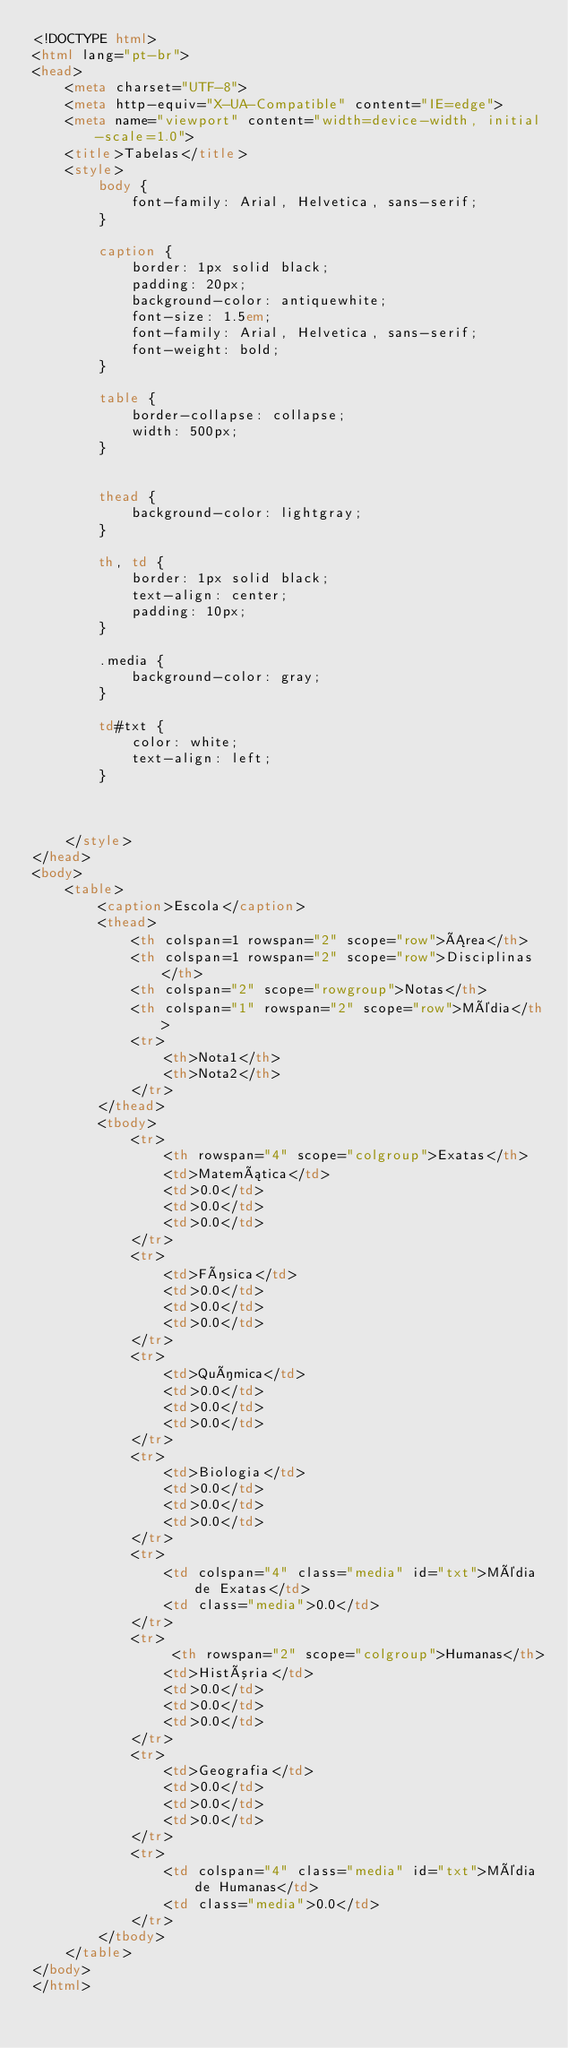<code> <loc_0><loc_0><loc_500><loc_500><_HTML_><!DOCTYPE html>
<html lang="pt-br">
<head>
    <meta charset="UTF-8">
    <meta http-equiv="X-UA-Compatible" content="IE=edge">
    <meta name="viewport" content="width=device-width, initial-scale=1.0">
    <title>Tabelas</title>
    <style>
        body {
            font-family: Arial, Helvetica, sans-serif;
        }

        caption {
            border: 1px solid black;
            padding: 20px;
            background-color: antiquewhite;
            font-size: 1.5em;
            font-family: Arial, Helvetica, sans-serif;
            font-weight: bold;
        }

        table {
            border-collapse: collapse;
            width: 500px;
        }


        thead {
            background-color: lightgray;
        }

        th, td {
            border: 1px solid black;
            text-align: center;
            padding: 10px;
        }

        .media {
            background-color: gray;
        }
        
        td#txt {
            color: white;
            text-align: left;
        }
        


    </style>
</head>
<body>
    <table>
        <caption>Escola</caption>
        <thead>
            <th colspan=1 rowspan="2" scope="row">Área</th>
            <th colspan=1 rowspan="2" scope="row">Disciplinas</th>
            <th colspan="2" scope="rowgroup">Notas</th>
            <th colspan="1" rowspan="2" scope="row">Média</th>
            <tr>
                <th>Nota1</th>
                <th>Nota2</th>
            </tr>
        </thead>
        <tbody>
            <tr>
                <th rowspan="4" scope="colgroup">Exatas</th>
                <td>Matemática</td>
                <td>0.0</td>
                <td>0.0</td>
                <td>0.0</td>
            </tr>
            <tr>
                <td>Física</td>
                <td>0.0</td>
                <td>0.0</td>
                <td>0.0</td>
            </tr>
            <tr>
                <td>Química</td>
                <td>0.0</td>
                <td>0.0</td>
                <td>0.0</td>
            </tr>
            <tr>
                <td>Biologia</td>
                <td>0.0</td>
                <td>0.0</td>
                <td>0.0</td>
            </tr>
            <tr>
                <td colspan="4" class="media" id="txt">Média de Exatas</td>
                <td class="media">0.0</td>
            </tr>
            <tr>
                 <th rowspan="2" scope="colgroup">Humanas</th>
                <td>História</td>
                <td>0.0</td>
                <td>0.0</td>
                <td>0.0</td>
            </tr>
            <tr>
                <td>Geografia</td>
                <td>0.0</td>
                <td>0.0</td>
                <td>0.0</td>
            </tr>
            <tr>
                <td colspan="4" class="media" id="txt">Média de Humanas</td>
                <td class="media">0.0</td>
            </tr>
        </tbody>
    </table>
</body>
</html></code> 